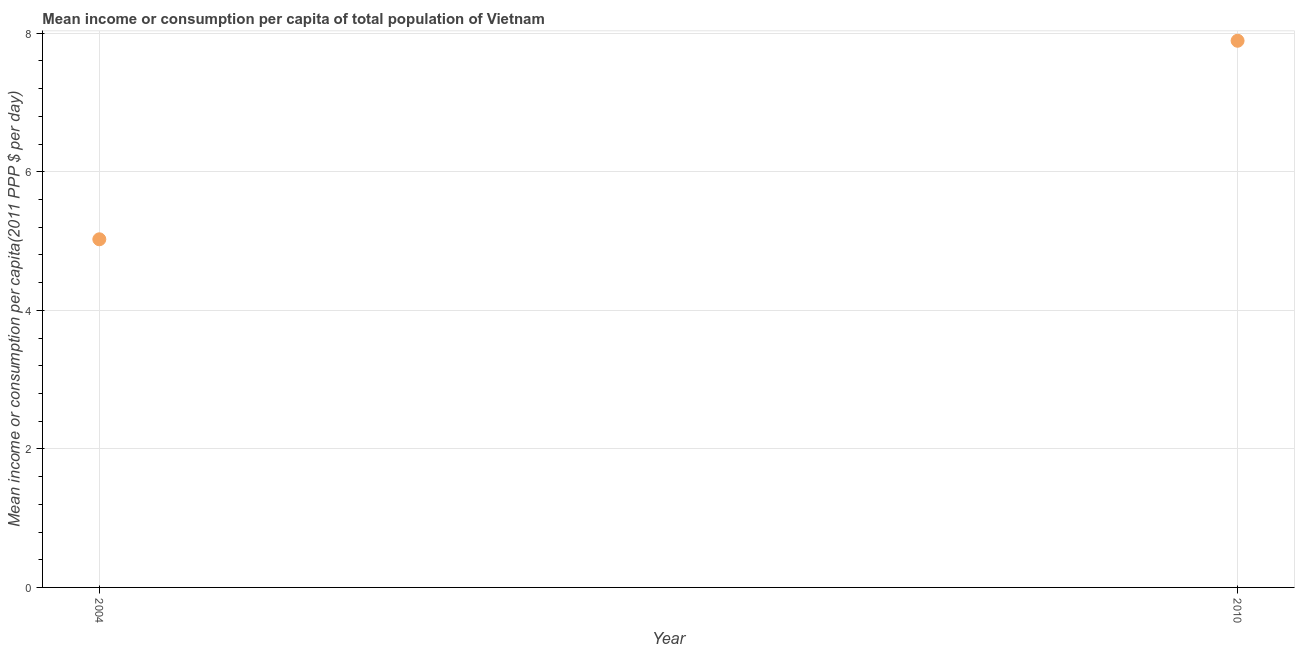What is the mean income or consumption in 2010?
Keep it short and to the point. 7.89. Across all years, what is the maximum mean income or consumption?
Provide a succinct answer. 7.89. Across all years, what is the minimum mean income or consumption?
Offer a very short reply. 5.03. In which year was the mean income or consumption maximum?
Keep it short and to the point. 2010. What is the sum of the mean income or consumption?
Offer a terse response. 12.92. What is the difference between the mean income or consumption in 2004 and 2010?
Your answer should be very brief. -2.87. What is the average mean income or consumption per year?
Give a very brief answer. 6.46. What is the median mean income or consumption?
Your answer should be very brief. 6.46. Do a majority of the years between 2004 and 2010 (inclusive) have mean income or consumption greater than 2 $?
Give a very brief answer. Yes. What is the ratio of the mean income or consumption in 2004 to that in 2010?
Keep it short and to the point. 0.64. Is the mean income or consumption in 2004 less than that in 2010?
Your answer should be compact. Yes. In how many years, is the mean income or consumption greater than the average mean income or consumption taken over all years?
Offer a very short reply. 1. What is the difference between two consecutive major ticks on the Y-axis?
Your answer should be compact. 2. Are the values on the major ticks of Y-axis written in scientific E-notation?
Give a very brief answer. No. Does the graph contain grids?
Your answer should be compact. Yes. What is the title of the graph?
Provide a succinct answer. Mean income or consumption per capita of total population of Vietnam. What is the label or title of the Y-axis?
Offer a very short reply. Mean income or consumption per capita(2011 PPP $ per day). What is the Mean income or consumption per capita(2011 PPP $ per day) in 2004?
Offer a terse response. 5.03. What is the Mean income or consumption per capita(2011 PPP $ per day) in 2010?
Make the answer very short. 7.89. What is the difference between the Mean income or consumption per capita(2011 PPP $ per day) in 2004 and 2010?
Your answer should be very brief. -2.87. What is the ratio of the Mean income or consumption per capita(2011 PPP $ per day) in 2004 to that in 2010?
Your answer should be very brief. 0.64. 